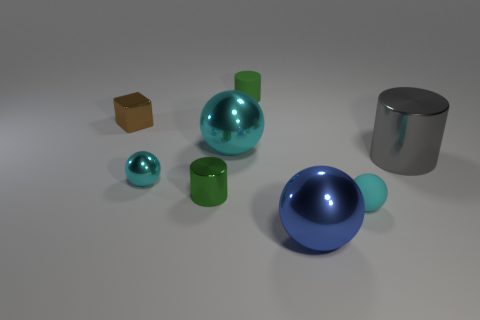There is a big thing that is on the left side of the blue ball; does it have the same shape as the tiny green thing on the left side of the large cyan shiny object?
Ensure brevity in your answer.  No. What number of big cyan spheres are left of the metal cube?
Give a very brief answer. 0. Do the small cyan object that is left of the large blue ball and the large cyan object have the same material?
Your answer should be very brief. Yes. There is another big thing that is the same shape as the green rubber thing; what color is it?
Keep it short and to the point. Gray. There is a cyan matte thing; what shape is it?
Ensure brevity in your answer.  Sphere. What number of objects are large blue rubber spheres or tiny things?
Provide a short and direct response. 5. There is a small matte object that is behind the tiny brown shiny block; is it the same color as the large cylinder in front of the tiny brown cube?
Your answer should be very brief. No. How many other objects are the same shape as the green metal object?
Make the answer very short. 2. Are there any small cyan things?
Give a very brief answer. Yes. What number of things are either cyan metal things or cyan objects that are to the right of the tiny green matte object?
Provide a short and direct response. 3. 